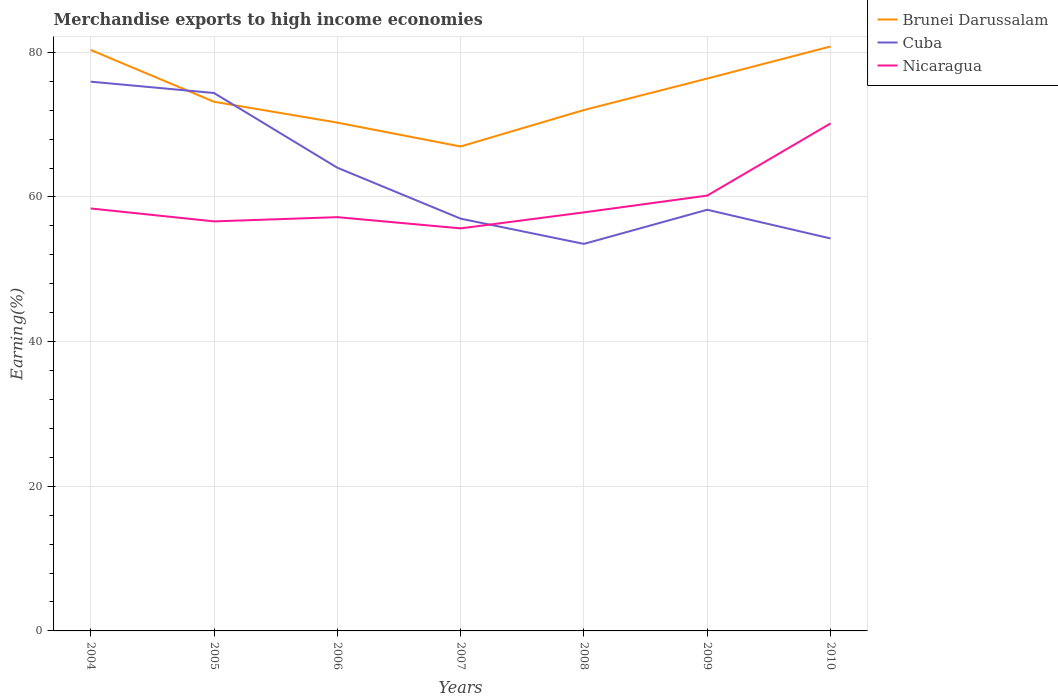Across all years, what is the maximum percentage of amount earned from merchandise exports in Brunei Darussalam?
Keep it short and to the point. 66.98. In which year was the percentage of amount earned from merchandise exports in Cuba maximum?
Your answer should be compact. 2008. What is the total percentage of amount earned from merchandise exports in Cuba in the graph?
Your answer should be very brief. 1.57. What is the difference between the highest and the second highest percentage of amount earned from merchandise exports in Brunei Darussalam?
Your response must be concise. 13.83. Is the percentage of amount earned from merchandise exports in Nicaragua strictly greater than the percentage of amount earned from merchandise exports in Brunei Darussalam over the years?
Make the answer very short. Yes. How many years are there in the graph?
Keep it short and to the point. 7. Does the graph contain grids?
Your response must be concise. Yes. Where does the legend appear in the graph?
Offer a terse response. Top right. How are the legend labels stacked?
Offer a terse response. Vertical. What is the title of the graph?
Make the answer very short. Merchandise exports to high income economies. What is the label or title of the X-axis?
Ensure brevity in your answer.  Years. What is the label or title of the Y-axis?
Your response must be concise. Earning(%). What is the Earning(%) in Brunei Darussalam in 2004?
Give a very brief answer. 80.32. What is the Earning(%) in Cuba in 2004?
Your answer should be very brief. 75.94. What is the Earning(%) in Nicaragua in 2004?
Keep it short and to the point. 58.41. What is the Earning(%) in Brunei Darussalam in 2005?
Your answer should be compact. 73.16. What is the Earning(%) of Cuba in 2005?
Give a very brief answer. 74.37. What is the Earning(%) of Nicaragua in 2005?
Provide a short and direct response. 56.62. What is the Earning(%) in Brunei Darussalam in 2006?
Make the answer very short. 70.27. What is the Earning(%) of Cuba in 2006?
Your response must be concise. 64.04. What is the Earning(%) of Nicaragua in 2006?
Your answer should be very brief. 57.21. What is the Earning(%) of Brunei Darussalam in 2007?
Provide a short and direct response. 66.98. What is the Earning(%) in Cuba in 2007?
Keep it short and to the point. 57. What is the Earning(%) in Nicaragua in 2007?
Keep it short and to the point. 55.65. What is the Earning(%) of Brunei Darussalam in 2008?
Your response must be concise. 72.02. What is the Earning(%) in Cuba in 2008?
Give a very brief answer. 53.51. What is the Earning(%) in Nicaragua in 2008?
Provide a succinct answer. 57.87. What is the Earning(%) of Brunei Darussalam in 2009?
Provide a short and direct response. 76.37. What is the Earning(%) in Cuba in 2009?
Provide a succinct answer. 58.23. What is the Earning(%) of Nicaragua in 2009?
Give a very brief answer. 60.19. What is the Earning(%) of Brunei Darussalam in 2010?
Offer a terse response. 80.81. What is the Earning(%) in Cuba in 2010?
Your answer should be compact. 54.26. What is the Earning(%) in Nicaragua in 2010?
Your response must be concise. 70.16. Across all years, what is the maximum Earning(%) in Brunei Darussalam?
Offer a terse response. 80.81. Across all years, what is the maximum Earning(%) in Cuba?
Provide a short and direct response. 75.94. Across all years, what is the maximum Earning(%) in Nicaragua?
Keep it short and to the point. 70.16. Across all years, what is the minimum Earning(%) of Brunei Darussalam?
Ensure brevity in your answer.  66.98. Across all years, what is the minimum Earning(%) in Cuba?
Offer a very short reply. 53.51. Across all years, what is the minimum Earning(%) of Nicaragua?
Provide a short and direct response. 55.65. What is the total Earning(%) of Brunei Darussalam in the graph?
Your answer should be very brief. 519.92. What is the total Earning(%) in Cuba in the graph?
Offer a very short reply. 437.35. What is the total Earning(%) in Nicaragua in the graph?
Keep it short and to the point. 416.1. What is the difference between the Earning(%) in Brunei Darussalam in 2004 and that in 2005?
Your answer should be compact. 7.17. What is the difference between the Earning(%) of Cuba in 2004 and that in 2005?
Offer a very short reply. 1.57. What is the difference between the Earning(%) in Nicaragua in 2004 and that in 2005?
Ensure brevity in your answer.  1.78. What is the difference between the Earning(%) of Brunei Darussalam in 2004 and that in 2006?
Offer a very short reply. 10.05. What is the difference between the Earning(%) of Cuba in 2004 and that in 2006?
Offer a terse response. 11.9. What is the difference between the Earning(%) of Nicaragua in 2004 and that in 2006?
Make the answer very short. 1.2. What is the difference between the Earning(%) in Brunei Darussalam in 2004 and that in 2007?
Offer a terse response. 13.35. What is the difference between the Earning(%) in Cuba in 2004 and that in 2007?
Provide a short and direct response. 18.94. What is the difference between the Earning(%) of Nicaragua in 2004 and that in 2007?
Provide a short and direct response. 2.75. What is the difference between the Earning(%) of Brunei Darussalam in 2004 and that in 2008?
Your answer should be compact. 8.31. What is the difference between the Earning(%) in Cuba in 2004 and that in 2008?
Offer a terse response. 22.43. What is the difference between the Earning(%) of Nicaragua in 2004 and that in 2008?
Your answer should be very brief. 0.54. What is the difference between the Earning(%) in Brunei Darussalam in 2004 and that in 2009?
Your response must be concise. 3.96. What is the difference between the Earning(%) of Cuba in 2004 and that in 2009?
Make the answer very short. 17.71. What is the difference between the Earning(%) in Nicaragua in 2004 and that in 2009?
Make the answer very short. -1.78. What is the difference between the Earning(%) of Brunei Darussalam in 2004 and that in 2010?
Give a very brief answer. -0.48. What is the difference between the Earning(%) in Cuba in 2004 and that in 2010?
Give a very brief answer. 21.68. What is the difference between the Earning(%) in Nicaragua in 2004 and that in 2010?
Provide a short and direct response. -11.76. What is the difference between the Earning(%) of Brunei Darussalam in 2005 and that in 2006?
Offer a terse response. 2.89. What is the difference between the Earning(%) in Cuba in 2005 and that in 2006?
Provide a succinct answer. 10.33. What is the difference between the Earning(%) of Nicaragua in 2005 and that in 2006?
Your answer should be compact. -0.58. What is the difference between the Earning(%) in Brunei Darussalam in 2005 and that in 2007?
Keep it short and to the point. 6.18. What is the difference between the Earning(%) in Cuba in 2005 and that in 2007?
Give a very brief answer. 17.37. What is the difference between the Earning(%) in Nicaragua in 2005 and that in 2007?
Make the answer very short. 0.97. What is the difference between the Earning(%) of Brunei Darussalam in 2005 and that in 2008?
Ensure brevity in your answer.  1.14. What is the difference between the Earning(%) in Cuba in 2005 and that in 2008?
Make the answer very short. 20.86. What is the difference between the Earning(%) of Nicaragua in 2005 and that in 2008?
Your answer should be very brief. -1.25. What is the difference between the Earning(%) of Brunei Darussalam in 2005 and that in 2009?
Give a very brief answer. -3.21. What is the difference between the Earning(%) in Cuba in 2005 and that in 2009?
Offer a terse response. 16.14. What is the difference between the Earning(%) of Nicaragua in 2005 and that in 2009?
Keep it short and to the point. -3.57. What is the difference between the Earning(%) in Brunei Darussalam in 2005 and that in 2010?
Your answer should be compact. -7.65. What is the difference between the Earning(%) of Cuba in 2005 and that in 2010?
Ensure brevity in your answer.  20.11. What is the difference between the Earning(%) in Nicaragua in 2005 and that in 2010?
Offer a terse response. -13.54. What is the difference between the Earning(%) of Brunei Darussalam in 2006 and that in 2007?
Give a very brief answer. 3.3. What is the difference between the Earning(%) in Cuba in 2006 and that in 2007?
Your answer should be compact. 7.04. What is the difference between the Earning(%) in Nicaragua in 2006 and that in 2007?
Your answer should be very brief. 1.55. What is the difference between the Earning(%) in Brunei Darussalam in 2006 and that in 2008?
Offer a terse response. -1.74. What is the difference between the Earning(%) in Cuba in 2006 and that in 2008?
Your answer should be compact. 10.53. What is the difference between the Earning(%) of Nicaragua in 2006 and that in 2008?
Give a very brief answer. -0.66. What is the difference between the Earning(%) in Brunei Darussalam in 2006 and that in 2009?
Give a very brief answer. -6.09. What is the difference between the Earning(%) in Cuba in 2006 and that in 2009?
Your answer should be very brief. 5.81. What is the difference between the Earning(%) in Nicaragua in 2006 and that in 2009?
Your answer should be very brief. -2.98. What is the difference between the Earning(%) of Brunei Darussalam in 2006 and that in 2010?
Provide a succinct answer. -10.53. What is the difference between the Earning(%) in Cuba in 2006 and that in 2010?
Offer a terse response. 9.78. What is the difference between the Earning(%) in Nicaragua in 2006 and that in 2010?
Give a very brief answer. -12.96. What is the difference between the Earning(%) of Brunei Darussalam in 2007 and that in 2008?
Keep it short and to the point. -5.04. What is the difference between the Earning(%) of Cuba in 2007 and that in 2008?
Your answer should be compact. 3.49. What is the difference between the Earning(%) of Nicaragua in 2007 and that in 2008?
Your response must be concise. -2.21. What is the difference between the Earning(%) in Brunei Darussalam in 2007 and that in 2009?
Your answer should be compact. -9.39. What is the difference between the Earning(%) of Cuba in 2007 and that in 2009?
Offer a terse response. -1.23. What is the difference between the Earning(%) of Nicaragua in 2007 and that in 2009?
Your answer should be compact. -4.53. What is the difference between the Earning(%) in Brunei Darussalam in 2007 and that in 2010?
Keep it short and to the point. -13.83. What is the difference between the Earning(%) in Cuba in 2007 and that in 2010?
Offer a very short reply. 2.74. What is the difference between the Earning(%) in Nicaragua in 2007 and that in 2010?
Your answer should be compact. -14.51. What is the difference between the Earning(%) in Brunei Darussalam in 2008 and that in 2009?
Give a very brief answer. -4.35. What is the difference between the Earning(%) of Cuba in 2008 and that in 2009?
Make the answer very short. -4.72. What is the difference between the Earning(%) in Nicaragua in 2008 and that in 2009?
Make the answer very short. -2.32. What is the difference between the Earning(%) of Brunei Darussalam in 2008 and that in 2010?
Ensure brevity in your answer.  -8.79. What is the difference between the Earning(%) of Cuba in 2008 and that in 2010?
Your answer should be very brief. -0.75. What is the difference between the Earning(%) in Nicaragua in 2008 and that in 2010?
Your answer should be compact. -12.3. What is the difference between the Earning(%) of Brunei Darussalam in 2009 and that in 2010?
Provide a short and direct response. -4.44. What is the difference between the Earning(%) of Cuba in 2009 and that in 2010?
Your response must be concise. 3.97. What is the difference between the Earning(%) of Nicaragua in 2009 and that in 2010?
Your answer should be very brief. -9.98. What is the difference between the Earning(%) in Brunei Darussalam in 2004 and the Earning(%) in Cuba in 2005?
Your response must be concise. 5.95. What is the difference between the Earning(%) in Brunei Darussalam in 2004 and the Earning(%) in Nicaragua in 2005?
Your answer should be very brief. 23.7. What is the difference between the Earning(%) in Cuba in 2004 and the Earning(%) in Nicaragua in 2005?
Keep it short and to the point. 19.32. What is the difference between the Earning(%) in Brunei Darussalam in 2004 and the Earning(%) in Cuba in 2006?
Keep it short and to the point. 16.28. What is the difference between the Earning(%) of Brunei Darussalam in 2004 and the Earning(%) of Nicaragua in 2006?
Your answer should be compact. 23.12. What is the difference between the Earning(%) in Cuba in 2004 and the Earning(%) in Nicaragua in 2006?
Your answer should be compact. 18.73. What is the difference between the Earning(%) in Brunei Darussalam in 2004 and the Earning(%) in Cuba in 2007?
Give a very brief answer. 23.33. What is the difference between the Earning(%) in Brunei Darussalam in 2004 and the Earning(%) in Nicaragua in 2007?
Offer a terse response. 24.67. What is the difference between the Earning(%) in Cuba in 2004 and the Earning(%) in Nicaragua in 2007?
Your answer should be compact. 20.28. What is the difference between the Earning(%) in Brunei Darussalam in 2004 and the Earning(%) in Cuba in 2008?
Your answer should be very brief. 26.82. What is the difference between the Earning(%) in Brunei Darussalam in 2004 and the Earning(%) in Nicaragua in 2008?
Your response must be concise. 22.46. What is the difference between the Earning(%) in Cuba in 2004 and the Earning(%) in Nicaragua in 2008?
Make the answer very short. 18.07. What is the difference between the Earning(%) of Brunei Darussalam in 2004 and the Earning(%) of Cuba in 2009?
Offer a very short reply. 22.1. What is the difference between the Earning(%) in Brunei Darussalam in 2004 and the Earning(%) in Nicaragua in 2009?
Provide a succinct answer. 20.14. What is the difference between the Earning(%) in Cuba in 2004 and the Earning(%) in Nicaragua in 2009?
Your answer should be compact. 15.75. What is the difference between the Earning(%) in Brunei Darussalam in 2004 and the Earning(%) in Cuba in 2010?
Provide a succinct answer. 26.07. What is the difference between the Earning(%) in Brunei Darussalam in 2004 and the Earning(%) in Nicaragua in 2010?
Your answer should be very brief. 10.16. What is the difference between the Earning(%) in Cuba in 2004 and the Earning(%) in Nicaragua in 2010?
Provide a succinct answer. 5.78. What is the difference between the Earning(%) in Brunei Darussalam in 2005 and the Earning(%) in Cuba in 2006?
Offer a terse response. 9.12. What is the difference between the Earning(%) in Brunei Darussalam in 2005 and the Earning(%) in Nicaragua in 2006?
Your answer should be compact. 15.95. What is the difference between the Earning(%) of Cuba in 2005 and the Earning(%) of Nicaragua in 2006?
Provide a short and direct response. 17.16. What is the difference between the Earning(%) of Brunei Darussalam in 2005 and the Earning(%) of Cuba in 2007?
Offer a terse response. 16.16. What is the difference between the Earning(%) of Brunei Darussalam in 2005 and the Earning(%) of Nicaragua in 2007?
Keep it short and to the point. 17.51. What is the difference between the Earning(%) in Cuba in 2005 and the Earning(%) in Nicaragua in 2007?
Offer a terse response. 18.72. What is the difference between the Earning(%) of Brunei Darussalam in 2005 and the Earning(%) of Cuba in 2008?
Your answer should be very brief. 19.65. What is the difference between the Earning(%) in Brunei Darussalam in 2005 and the Earning(%) in Nicaragua in 2008?
Provide a short and direct response. 15.29. What is the difference between the Earning(%) in Cuba in 2005 and the Earning(%) in Nicaragua in 2008?
Your response must be concise. 16.5. What is the difference between the Earning(%) in Brunei Darussalam in 2005 and the Earning(%) in Cuba in 2009?
Your answer should be very brief. 14.93. What is the difference between the Earning(%) of Brunei Darussalam in 2005 and the Earning(%) of Nicaragua in 2009?
Your answer should be compact. 12.97. What is the difference between the Earning(%) in Cuba in 2005 and the Earning(%) in Nicaragua in 2009?
Make the answer very short. 14.18. What is the difference between the Earning(%) of Brunei Darussalam in 2005 and the Earning(%) of Cuba in 2010?
Your response must be concise. 18.9. What is the difference between the Earning(%) in Brunei Darussalam in 2005 and the Earning(%) in Nicaragua in 2010?
Provide a short and direct response. 3. What is the difference between the Earning(%) of Cuba in 2005 and the Earning(%) of Nicaragua in 2010?
Make the answer very short. 4.21. What is the difference between the Earning(%) of Brunei Darussalam in 2006 and the Earning(%) of Cuba in 2007?
Provide a short and direct response. 13.28. What is the difference between the Earning(%) in Brunei Darussalam in 2006 and the Earning(%) in Nicaragua in 2007?
Provide a short and direct response. 14.62. What is the difference between the Earning(%) of Cuba in 2006 and the Earning(%) of Nicaragua in 2007?
Offer a very short reply. 8.39. What is the difference between the Earning(%) of Brunei Darussalam in 2006 and the Earning(%) of Cuba in 2008?
Ensure brevity in your answer.  16.77. What is the difference between the Earning(%) in Brunei Darussalam in 2006 and the Earning(%) in Nicaragua in 2008?
Offer a very short reply. 12.41. What is the difference between the Earning(%) in Cuba in 2006 and the Earning(%) in Nicaragua in 2008?
Your answer should be compact. 6.18. What is the difference between the Earning(%) in Brunei Darussalam in 2006 and the Earning(%) in Cuba in 2009?
Provide a succinct answer. 12.05. What is the difference between the Earning(%) in Brunei Darussalam in 2006 and the Earning(%) in Nicaragua in 2009?
Offer a very short reply. 10.09. What is the difference between the Earning(%) of Cuba in 2006 and the Earning(%) of Nicaragua in 2009?
Offer a terse response. 3.85. What is the difference between the Earning(%) in Brunei Darussalam in 2006 and the Earning(%) in Cuba in 2010?
Your answer should be compact. 16.02. What is the difference between the Earning(%) of Brunei Darussalam in 2006 and the Earning(%) of Nicaragua in 2010?
Your answer should be very brief. 0.11. What is the difference between the Earning(%) of Cuba in 2006 and the Earning(%) of Nicaragua in 2010?
Give a very brief answer. -6.12. What is the difference between the Earning(%) of Brunei Darussalam in 2007 and the Earning(%) of Cuba in 2008?
Your response must be concise. 13.47. What is the difference between the Earning(%) in Brunei Darussalam in 2007 and the Earning(%) in Nicaragua in 2008?
Keep it short and to the point. 9.11. What is the difference between the Earning(%) of Cuba in 2007 and the Earning(%) of Nicaragua in 2008?
Offer a very short reply. -0.87. What is the difference between the Earning(%) in Brunei Darussalam in 2007 and the Earning(%) in Cuba in 2009?
Provide a succinct answer. 8.75. What is the difference between the Earning(%) in Brunei Darussalam in 2007 and the Earning(%) in Nicaragua in 2009?
Your answer should be compact. 6.79. What is the difference between the Earning(%) in Cuba in 2007 and the Earning(%) in Nicaragua in 2009?
Your response must be concise. -3.19. What is the difference between the Earning(%) of Brunei Darussalam in 2007 and the Earning(%) of Cuba in 2010?
Your response must be concise. 12.72. What is the difference between the Earning(%) of Brunei Darussalam in 2007 and the Earning(%) of Nicaragua in 2010?
Provide a short and direct response. -3.19. What is the difference between the Earning(%) in Cuba in 2007 and the Earning(%) in Nicaragua in 2010?
Keep it short and to the point. -13.16. What is the difference between the Earning(%) in Brunei Darussalam in 2008 and the Earning(%) in Cuba in 2009?
Your response must be concise. 13.79. What is the difference between the Earning(%) of Brunei Darussalam in 2008 and the Earning(%) of Nicaragua in 2009?
Make the answer very short. 11.83. What is the difference between the Earning(%) in Cuba in 2008 and the Earning(%) in Nicaragua in 2009?
Provide a succinct answer. -6.68. What is the difference between the Earning(%) of Brunei Darussalam in 2008 and the Earning(%) of Cuba in 2010?
Provide a succinct answer. 17.76. What is the difference between the Earning(%) in Brunei Darussalam in 2008 and the Earning(%) in Nicaragua in 2010?
Give a very brief answer. 1.85. What is the difference between the Earning(%) of Cuba in 2008 and the Earning(%) of Nicaragua in 2010?
Make the answer very short. -16.65. What is the difference between the Earning(%) of Brunei Darussalam in 2009 and the Earning(%) of Cuba in 2010?
Make the answer very short. 22.11. What is the difference between the Earning(%) of Brunei Darussalam in 2009 and the Earning(%) of Nicaragua in 2010?
Keep it short and to the point. 6.21. What is the difference between the Earning(%) in Cuba in 2009 and the Earning(%) in Nicaragua in 2010?
Ensure brevity in your answer.  -11.93. What is the average Earning(%) of Brunei Darussalam per year?
Your answer should be compact. 74.27. What is the average Earning(%) in Cuba per year?
Offer a terse response. 62.48. What is the average Earning(%) of Nicaragua per year?
Ensure brevity in your answer.  59.44. In the year 2004, what is the difference between the Earning(%) in Brunei Darussalam and Earning(%) in Cuba?
Make the answer very short. 4.39. In the year 2004, what is the difference between the Earning(%) of Brunei Darussalam and Earning(%) of Nicaragua?
Your answer should be very brief. 21.92. In the year 2004, what is the difference between the Earning(%) in Cuba and Earning(%) in Nicaragua?
Make the answer very short. 17.53. In the year 2005, what is the difference between the Earning(%) of Brunei Darussalam and Earning(%) of Cuba?
Make the answer very short. -1.21. In the year 2005, what is the difference between the Earning(%) in Brunei Darussalam and Earning(%) in Nicaragua?
Provide a succinct answer. 16.54. In the year 2005, what is the difference between the Earning(%) in Cuba and Earning(%) in Nicaragua?
Give a very brief answer. 17.75. In the year 2006, what is the difference between the Earning(%) of Brunei Darussalam and Earning(%) of Cuba?
Keep it short and to the point. 6.23. In the year 2006, what is the difference between the Earning(%) in Brunei Darussalam and Earning(%) in Nicaragua?
Your answer should be very brief. 13.07. In the year 2006, what is the difference between the Earning(%) in Cuba and Earning(%) in Nicaragua?
Keep it short and to the point. 6.84. In the year 2007, what is the difference between the Earning(%) in Brunei Darussalam and Earning(%) in Cuba?
Keep it short and to the point. 9.98. In the year 2007, what is the difference between the Earning(%) of Brunei Darussalam and Earning(%) of Nicaragua?
Make the answer very short. 11.32. In the year 2007, what is the difference between the Earning(%) of Cuba and Earning(%) of Nicaragua?
Ensure brevity in your answer.  1.34. In the year 2008, what is the difference between the Earning(%) in Brunei Darussalam and Earning(%) in Cuba?
Make the answer very short. 18.51. In the year 2008, what is the difference between the Earning(%) of Brunei Darussalam and Earning(%) of Nicaragua?
Give a very brief answer. 14.15. In the year 2008, what is the difference between the Earning(%) in Cuba and Earning(%) in Nicaragua?
Your answer should be very brief. -4.36. In the year 2009, what is the difference between the Earning(%) of Brunei Darussalam and Earning(%) of Cuba?
Make the answer very short. 18.14. In the year 2009, what is the difference between the Earning(%) of Brunei Darussalam and Earning(%) of Nicaragua?
Give a very brief answer. 16.18. In the year 2009, what is the difference between the Earning(%) in Cuba and Earning(%) in Nicaragua?
Offer a very short reply. -1.96. In the year 2010, what is the difference between the Earning(%) in Brunei Darussalam and Earning(%) in Cuba?
Your answer should be compact. 26.55. In the year 2010, what is the difference between the Earning(%) in Brunei Darussalam and Earning(%) in Nicaragua?
Your response must be concise. 10.64. In the year 2010, what is the difference between the Earning(%) in Cuba and Earning(%) in Nicaragua?
Offer a very short reply. -15.9. What is the ratio of the Earning(%) in Brunei Darussalam in 2004 to that in 2005?
Keep it short and to the point. 1.1. What is the ratio of the Earning(%) of Cuba in 2004 to that in 2005?
Make the answer very short. 1.02. What is the ratio of the Earning(%) of Nicaragua in 2004 to that in 2005?
Provide a short and direct response. 1.03. What is the ratio of the Earning(%) in Brunei Darussalam in 2004 to that in 2006?
Your response must be concise. 1.14. What is the ratio of the Earning(%) of Cuba in 2004 to that in 2006?
Your response must be concise. 1.19. What is the ratio of the Earning(%) in Nicaragua in 2004 to that in 2006?
Provide a succinct answer. 1.02. What is the ratio of the Earning(%) in Brunei Darussalam in 2004 to that in 2007?
Your answer should be very brief. 1.2. What is the ratio of the Earning(%) of Cuba in 2004 to that in 2007?
Your answer should be compact. 1.33. What is the ratio of the Earning(%) in Nicaragua in 2004 to that in 2007?
Make the answer very short. 1.05. What is the ratio of the Earning(%) of Brunei Darussalam in 2004 to that in 2008?
Offer a very short reply. 1.12. What is the ratio of the Earning(%) of Cuba in 2004 to that in 2008?
Provide a succinct answer. 1.42. What is the ratio of the Earning(%) of Nicaragua in 2004 to that in 2008?
Provide a short and direct response. 1.01. What is the ratio of the Earning(%) in Brunei Darussalam in 2004 to that in 2009?
Keep it short and to the point. 1.05. What is the ratio of the Earning(%) in Cuba in 2004 to that in 2009?
Make the answer very short. 1.3. What is the ratio of the Earning(%) in Nicaragua in 2004 to that in 2009?
Give a very brief answer. 0.97. What is the ratio of the Earning(%) of Brunei Darussalam in 2004 to that in 2010?
Provide a succinct answer. 0.99. What is the ratio of the Earning(%) in Cuba in 2004 to that in 2010?
Keep it short and to the point. 1.4. What is the ratio of the Earning(%) of Nicaragua in 2004 to that in 2010?
Ensure brevity in your answer.  0.83. What is the ratio of the Earning(%) in Brunei Darussalam in 2005 to that in 2006?
Give a very brief answer. 1.04. What is the ratio of the Earning(%) in Cuba in 2005 to that in 2006?
Ensure brevity in your answer.  1.16. What is the ratio of the Earning(%) in Nicaragua in 2005 to that in 2006?
Give a very brief answer. 0.99. What is the ratio of the Earning(%) of Brunei Darussalam in 2005 to that in 2007?
Make the answer very short. 1.09. What is the ratio of the Earning(%) in Cuba in 2005 to that in 2007?
Provide a short and direct response. 1.3. What is the ratio of the Earning(%) in Nicaragua in 2005 to that in 2007?
Your response must be concise. 1.02. What is the ratio of the Earning(%) in Brunei Darussalam in 2005 to that in 2008?
Offer a very short reply. 1.02. What is the ratio of the Earning(%) of Cuba in 2005 to that in 2008?
Ensure brevity in your answer.  1.39. What is the ratio of the Earning(%) of Nicaragua in 2005 to that in 2008?
Offer a very short reply. 0.98. What is the ratio of the Earning(%) in Brunei Darussalam in 2005 to that in 2009?
Make the answer very short. 0.96. What is the ratio of the Earning(%) of Cuba in 2005 to that in 2009?
Provide a short and direct response. 1.28. What is the ratio of the Earning(%) of Nicaragua in 2005 to that in 2009?
Your answer should be very brief. 0.94. What is the ratio of the Earning(%) in Brunei Darussalam in 2005 to that in 2010?
Ensure brevity in your answer.  0.91. What is the ratio of the Earning(%) of Cuba in 2005 to that in 2010?
Ensure brevity in your answer.  1.37. What is the ratio of the Earning(%) in Nicaragua in 2005 to that in 2010?
Keep it short and to the point. 0.81. What is the ratio of the Earning(%) in Brunei Darussalam in 2006 to that in 2007?
Your answer should be very brief. 1.05. What is the ratio of the Earning(%) of Cuba in 2006 to that in 2007?
Your response must be concise. 1.12. What is the ratio of the Earning(%) in Nicaragua in 2006 to that in 2007?
Provide a short and direct response. 1.03. What is the ratio of the Earning(%) in Brunei Darussalam in 2006 to that in 2008?
Offer a very short reply. 0.98. What is the ratio of the Earning(%) of Cuba in 2006 to that in 2008?
Make the answer very short. 1.2. What is the ratio of the Earning(%) in Brunei Darussalam in 2006 to that in 2009?
Give a very brief answer. 0.92. What is the ratio of the Earning(%) in Cuba in 2006 to that in 2009?
Your answer should be compact. 1.1. What is the ratio of the Earning(%) in Nicaragua in 2006 to that in 2009?
Your answer should be compact. 0.95. What is the ratio of the Earning(%) of Brunei Darussalam in 2006 to that in 2010?
Make the answer very short. 0.87. What is the ratio of the Earning(%) of Cuba in 2006 to that in 2010?
Make the answer very short. 1.18. What is the ratio of the Earning(%) in Nicaragua in 2006 to that in 2010?
Keep it short and to the point. 0.82. What is the ratio of the Earning(%) of Cuba in 2007 to that in 2008?
Ensure brevity in your answer.  1.07. What is the ratio of the Earning(%) of Nicaragua in 2007 to that in 2008?
Your answer should be very brief. 0.96. What is the ratio of the Earning(%) of Brunei Darussalam in 2007 to that in 2009?
Provide a short and direct response. 0.88. What is the ratio of the Earning(%) of Cuba in 2007 to that in 2009?
Offer a terse response. 0.98. What is the ratio of the Earning(%) of Nicaragua in 2007 to that in 2009?
Make the answer very short. 0.92. What is the ratio of the Earning(%) of Brunei Darussalam in 2007 to that in 2010?
Your answer should be very brief. 0.83. What is the ratio of the Earning(%) of Cuba in 2007 to that in 2010?
Keep it short and to the point. 1.05. What is the ratio of the Earning(%) of Nicaragua in 2007 to that in 2010?
Provide a short and direct response. 0.79. What is the ratio of the Earning(%) in Brunei Darussalam in 2008 to that in 2009?
Your answer should be very brief. 0.94. What is the ratio of the Earning(%) in Cuba in 2008 to that in 2009?
Ensure brevity in your answer.  0.92. What is the ratio of the Earning(%) in Nicaragua in 2008 to that in 2009?
Provide a succinct answer. 0.96. What is the ratio of the Earning(%) in Brunei Darussalam in 2008 to that in 2010?
Offer a very short reply. 0.89. What is the ratio of the Earning(%) of Cuba in 2008 to that in 2010?
Provide a succinct answer. 0.99. What is the ratio of the Earning(%) in Nicaragua in 2008 to that in 2010?
Your answer should be very brief. 0.82. What is the ratio of the Earning(%) of Brunei Darussalam in 2009 to that in 2010?
Your answer should be compact. 0.95. What is the ratio of the Earning(%) in Cuba in 2009 to that in 2010?
Offer a terse response. 1.07. What is the ratio of the Earning(%) of Nicaragua in 2009 to that in 2010?
Keep it short and to the point. 0.86. What is the difference between the highest and the second highest Earning(%) of Brunei Darussalam?
Ensure brevity in your answer.  0.48. What is the difference between the highest and the second highest Earning(%) in Cuba?
Offer a very short reply. 1.57. What is the difference between the highest and the second highest Earning(%) of Nicaragua?
Give a very brief answer. 9.98. What is the difference between the highest and the lowest Earning(%) in Brunei Darussalam?
Make the answer very short. 13.83. What is the difference between the highest and the lowest Earning(%) of Cuba?
Ensure brevity in your answer.  22.43. What is the difference between the highest and the lowest Earning(%) in Nicaragua?
Keep it short and to the point. 14.51. 